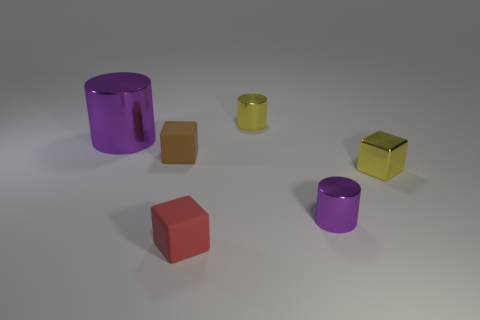Add 4 tiny cyan metallic blocks. How many objects exist? 10 Subtract all big purple cylinders. Subtract all small yellow cylinders. How many objects are left? 4 Add 2 small objects. How many small objects are left? 7 Add 1 small brown things. How many small brown things exist? 2 Subtract 0 yellow balls. How many objects are left? 6 